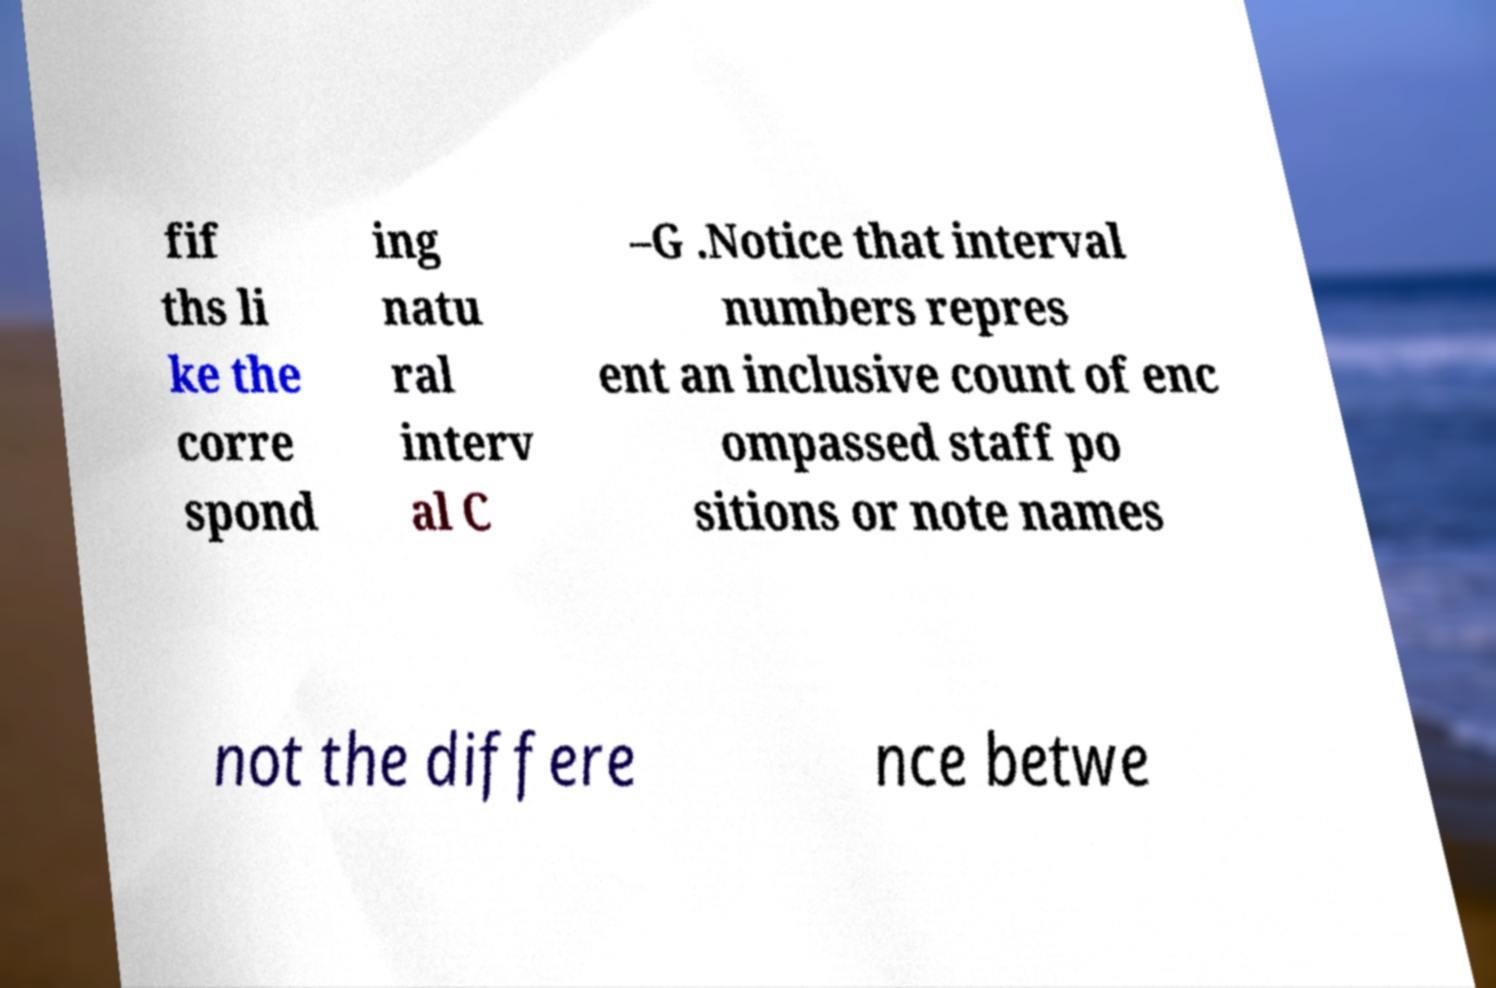Could you assist in decoding the text presented in this image and type it out clearly? fif ths li ke the corre spond ing natu ral interv al C –G .Notice that interval numbers repres ent an inclusive count of enc ompassed staff po sitions or note names not the differe nce betwe 